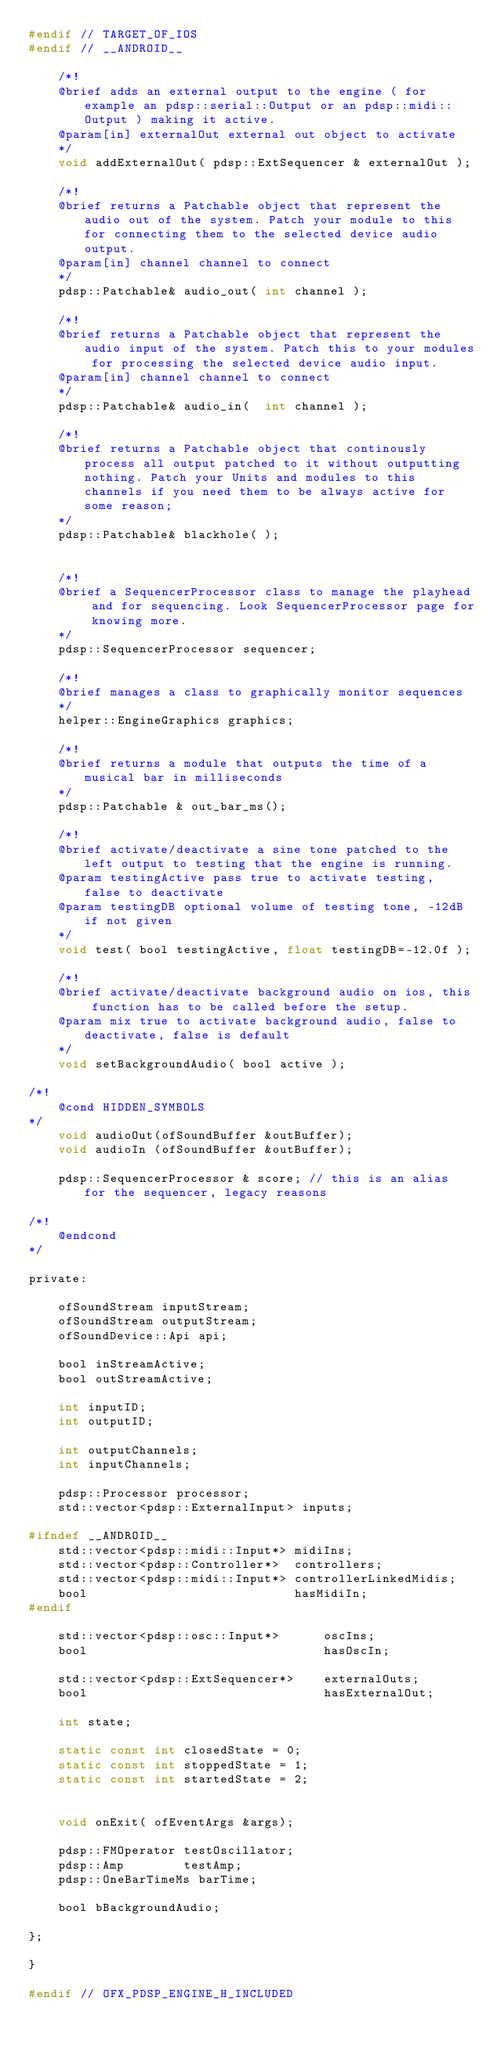Convert code to text. <code><loc_0><loc_0><loc_500><loc_500><_C_>#endif // TARGET_OF_IOS
#endif // __ANDROID__
    
    /*!
    @brief adds an external output to the engine ( for example an pdsp::serial::Output or an pdsp::midi::Output ) making it active.
    @param[in] externalOut external out object to activate
    */
    void addExternalOut( pdsp::ExtSequencer & externalOut );

    /*!
    @brief returns a Patchable object that represent the audio out of the system. Patch your module to this for connecting them to the selected device audio output.
    @param[in] channel channel to connect
    */
    pdsp::Patchable& audio_out( int channel );
    
    /*!
    @brief returns a Patchable object that represent the audio input of the system. Patch this to your modules for processing the selected device audio input.
    @param[in] channel channel to connect
    */
    pdsp::Patchable& audio_in(  int channel );
    
    /*!
    @brief returns a Patchable object that continously process all output patched to it without outputting nothing. Patch your Units and modules to this channels if you need them to be always active for some reason;
    */    
    pdsp::Patchable& blackhole( );
    

    /*!
    @brief a SequencerProcessor class to manage the playhead and for sequencing. Look SequencerProcessor page for knowing more.
    */
    pdsp::SequencerProcessor sequencer;
    
    /*!
    @brief manages a class to graphically monitor sequences
    */    
    helper::EngineGraphics graphics;
   
    /*!
    @brief returns a module that outputs the time of a musical bar in milliseconds
    */    
    pdsp::Patchable & out_bar_ms();
           
    /*!
    @brief activate/deactivate a sine tone patched to the left output to testing that the engine is running.
    @param testingActive pass true to activate testing, false to deactivate
    @param testingDB optional volume of testing tone, -12dB if not given
    */       
    void test( bool testingActive, float testingDB=-12.0f );

    /*!
    @brief activate/deactivate background audio on ios, this function has to be called before the setup.
    @param mix true to activate background audio, false to deactivate, false is default
    */   
    void setBackgroundAudio( bool active );

/*!
    @cond HIDDEN_SYMBOLS
*/
    void audioOut(ofSoundBuffer &outBuffer);
    void audioIn (ofSoundBuffer &outBuffer);
    
    pdsp::SequencerProcessor & score; // this is an alias for the sequencer, legacy reasons

/*!
    @endcond
*/

private:

    ofSoundStream inputStream;
    ofSoundStream outputStream;
    ofSoundDevice::Api api;
    
    bool inStreamActive;
    bool outStreamActive;    
    
    int inputID;
    int outputID;
    
    int outputChannels;
    int inputChannels;
        
    pdsp::Processor processor;
    std::vector<pdsp::ExternalInput> inputs;

#ifndef __ANDROID__
    std::vector<pdsp::midi::Input*> midiIns;
    std::vector<pdsp::Controller*>  controllers;
    std::vector<pdsp::midi::Input*> controllerLinkedMidis;
    bool                            hasMidiIn;
#endif

    std::vector<pdsp::osc::Input*>      oscIns;
    bool                                hasOscIn;

    std::vector<pdsp::ExtSequencer*>    externalOuts;  
    bool                                hasExternalOut;
    
    int state;

    static const int closedState = 0;
    static const int stoppedState = 1;
    static const int startedState = 2;


    void onExit( ofEventArgs &args);
    
    pdsp::FMOperator testOscillator;
    pdsp::Amp        testAmp;
    pdsp::OneBarTimeMs barTime;
    
    bool bBackgroundAudio;
        
};

}

#endif // OFX_PDSP_ENGINE_H_INCLUDED
</code> 